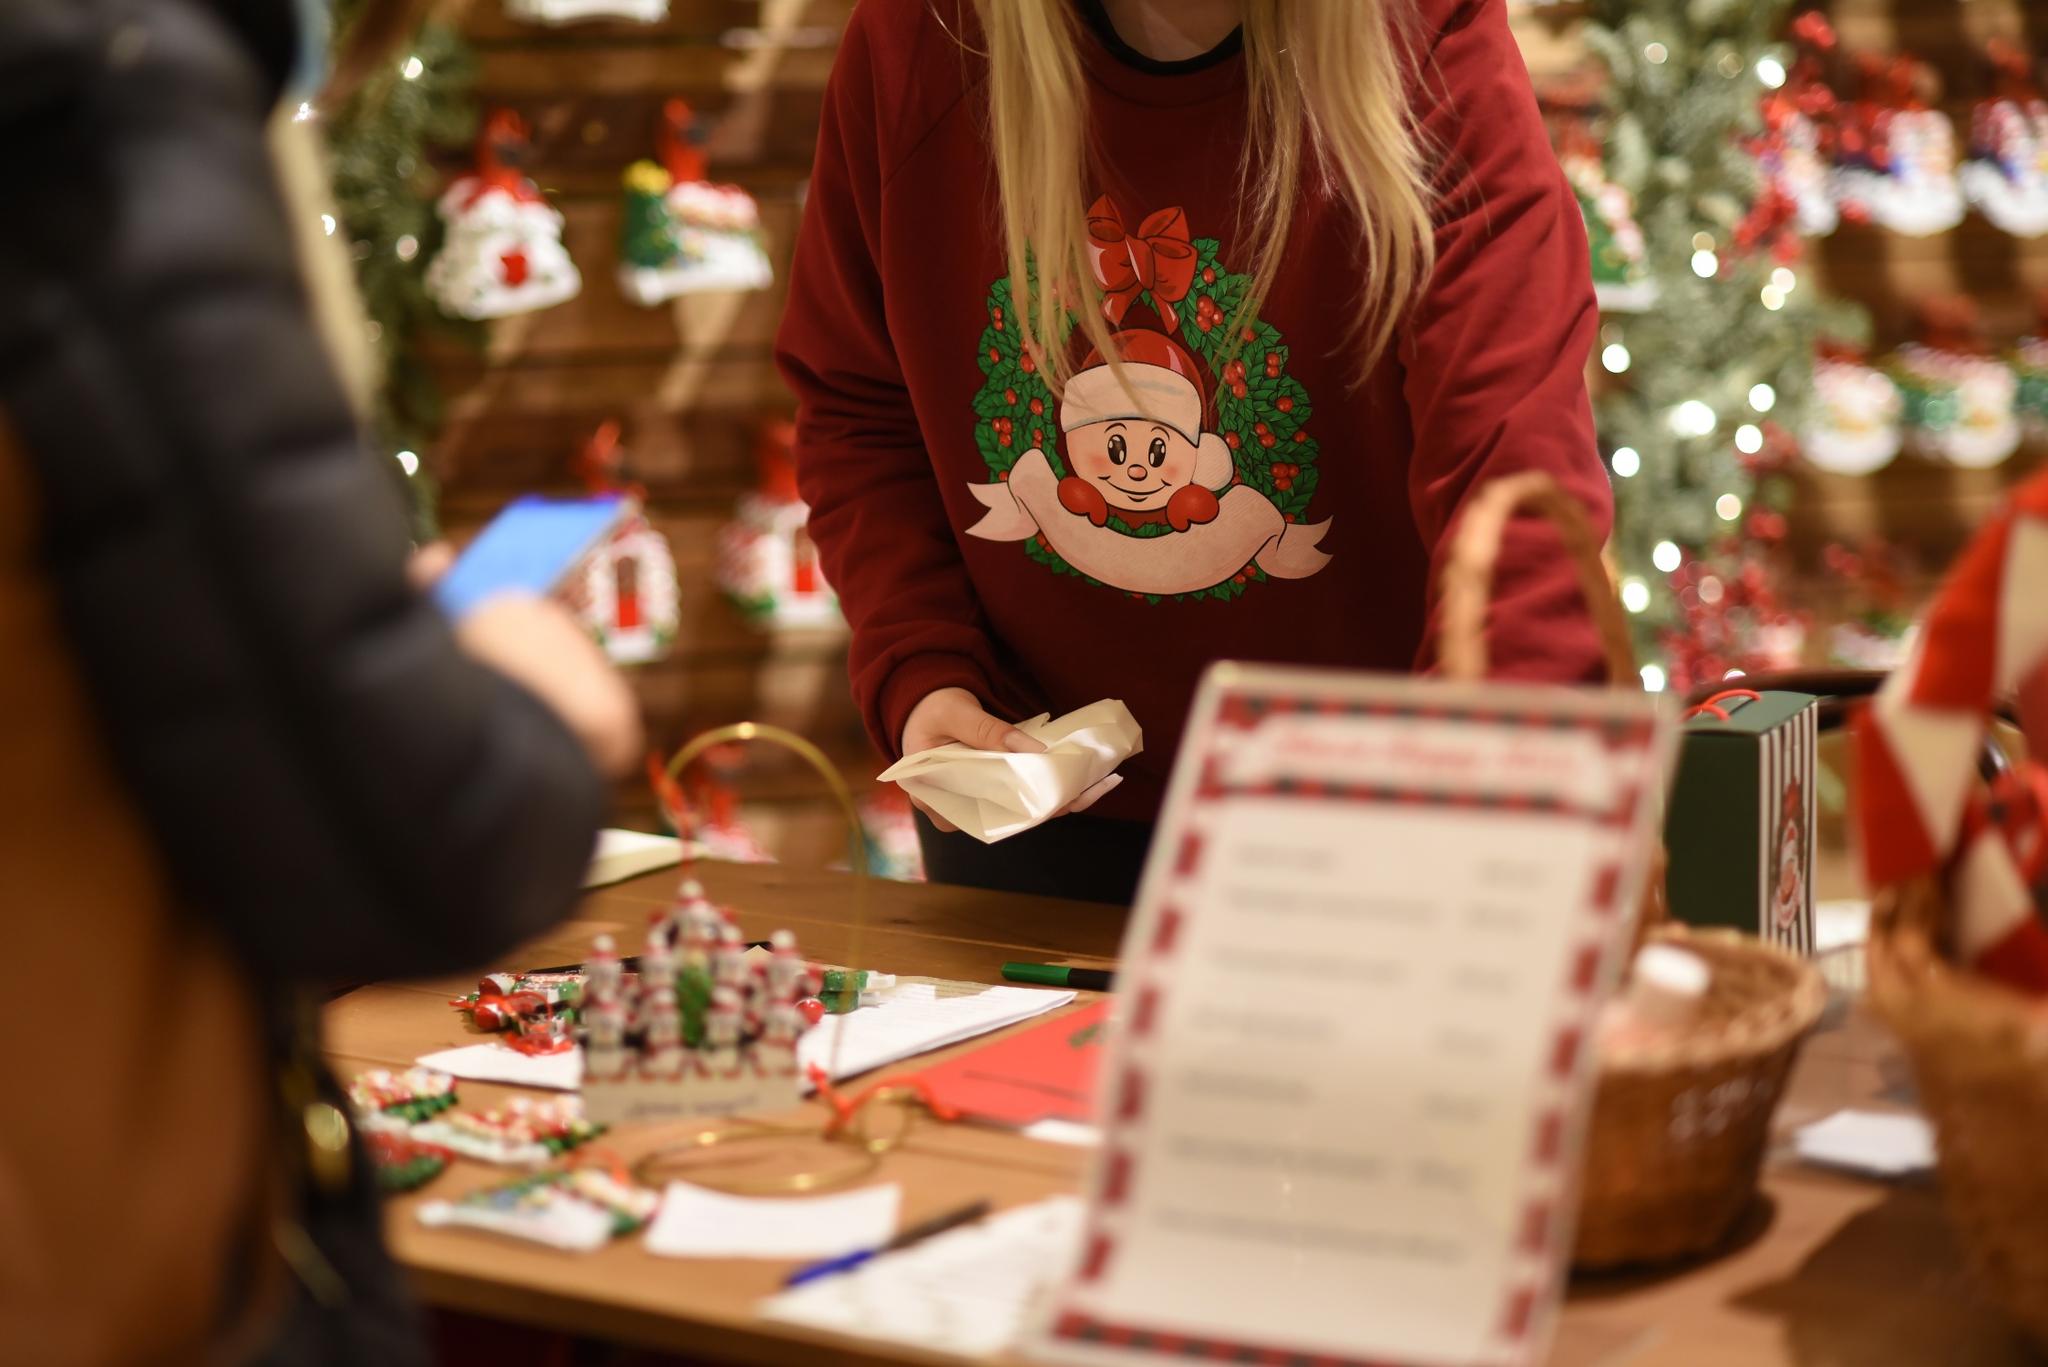If the decorations in this store could come to life, what do you imagine they would do? Imagine the decorations in the store magically coming to life at midnight. The tiny, handmade ornaments would spring into action, orchestrating a grand festive celebration. The festive wreaths hanging on the wall would begin to sway and sing harmonious Christmas carols. The miniature Santa figurines, with twinkling eyes, would climb down from the shelves and start preparing tiny gifts for other decorations. The Christmas tree would light up even brighter, with its ornaments dancing and spinning in sync with the festive music. The candy canes and gingerbread men would leap from their baskets, performing a cheerful dance, bringing an extra dose of holiday magic. As dawn approaches, all the decorations would rush back to their places, ensuring everything is in perfect order for the morning visitors, leaving an enchanting and heartwarming feeling lingering in the air. 